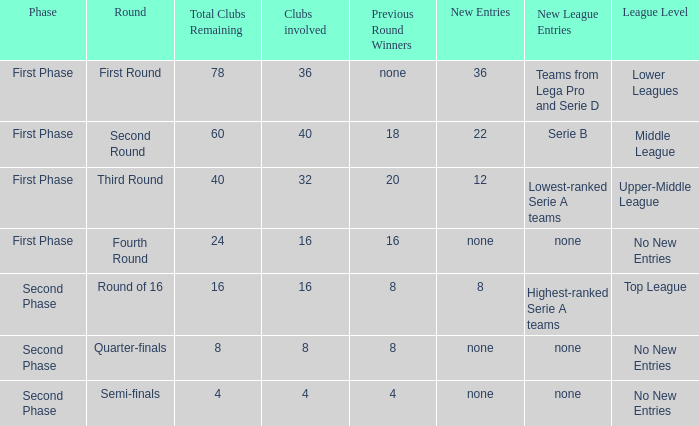Could you help me parse every detail presented in this table? {'header': ['Phase', 'Round', 'Total Clubs Remaining', 'Clubs involved', 'Previous Round Winners', 'New Entries', 'New League Entries', 'League Level'], 'rows': [['First Phase', 'First Round', '78', '36', 'none', '36', 'Teams from Lega Pro and Serie D', 'Lower Leagues'], ['First Phase', 'Second Round', '60', '40', '18', '22', 'Serie B', 'Middle League'], ['First Phase', 'Third Round', '40', '32', '20', '12', 'Lowest-ranked Serie A teams', 'Upper-Middle League'], ['First Phase', 'Fourth Round', '24', '16', '16', 'none', 'none', 'No New Entries'], ['Second Phase', 'Round of 16', '16', '16', '8', '8', 'Highest-ranked Serie A teams', 'Top League'], ['Second Phase', 'Quarter-finals', '8', '8', '8', 'none', 'none', 'No New Entries'], ['Second Phase', 'Semi-finals', '4', '4', '4', 'none', 'none', 'No New Entries']]} From the round name of third round; what would the new entries this round that would be found? 12.0. 